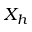Convert formula to latex. <formula><loc_0><loc_0><loc_500><loc_500>X _ { h }</formula> 